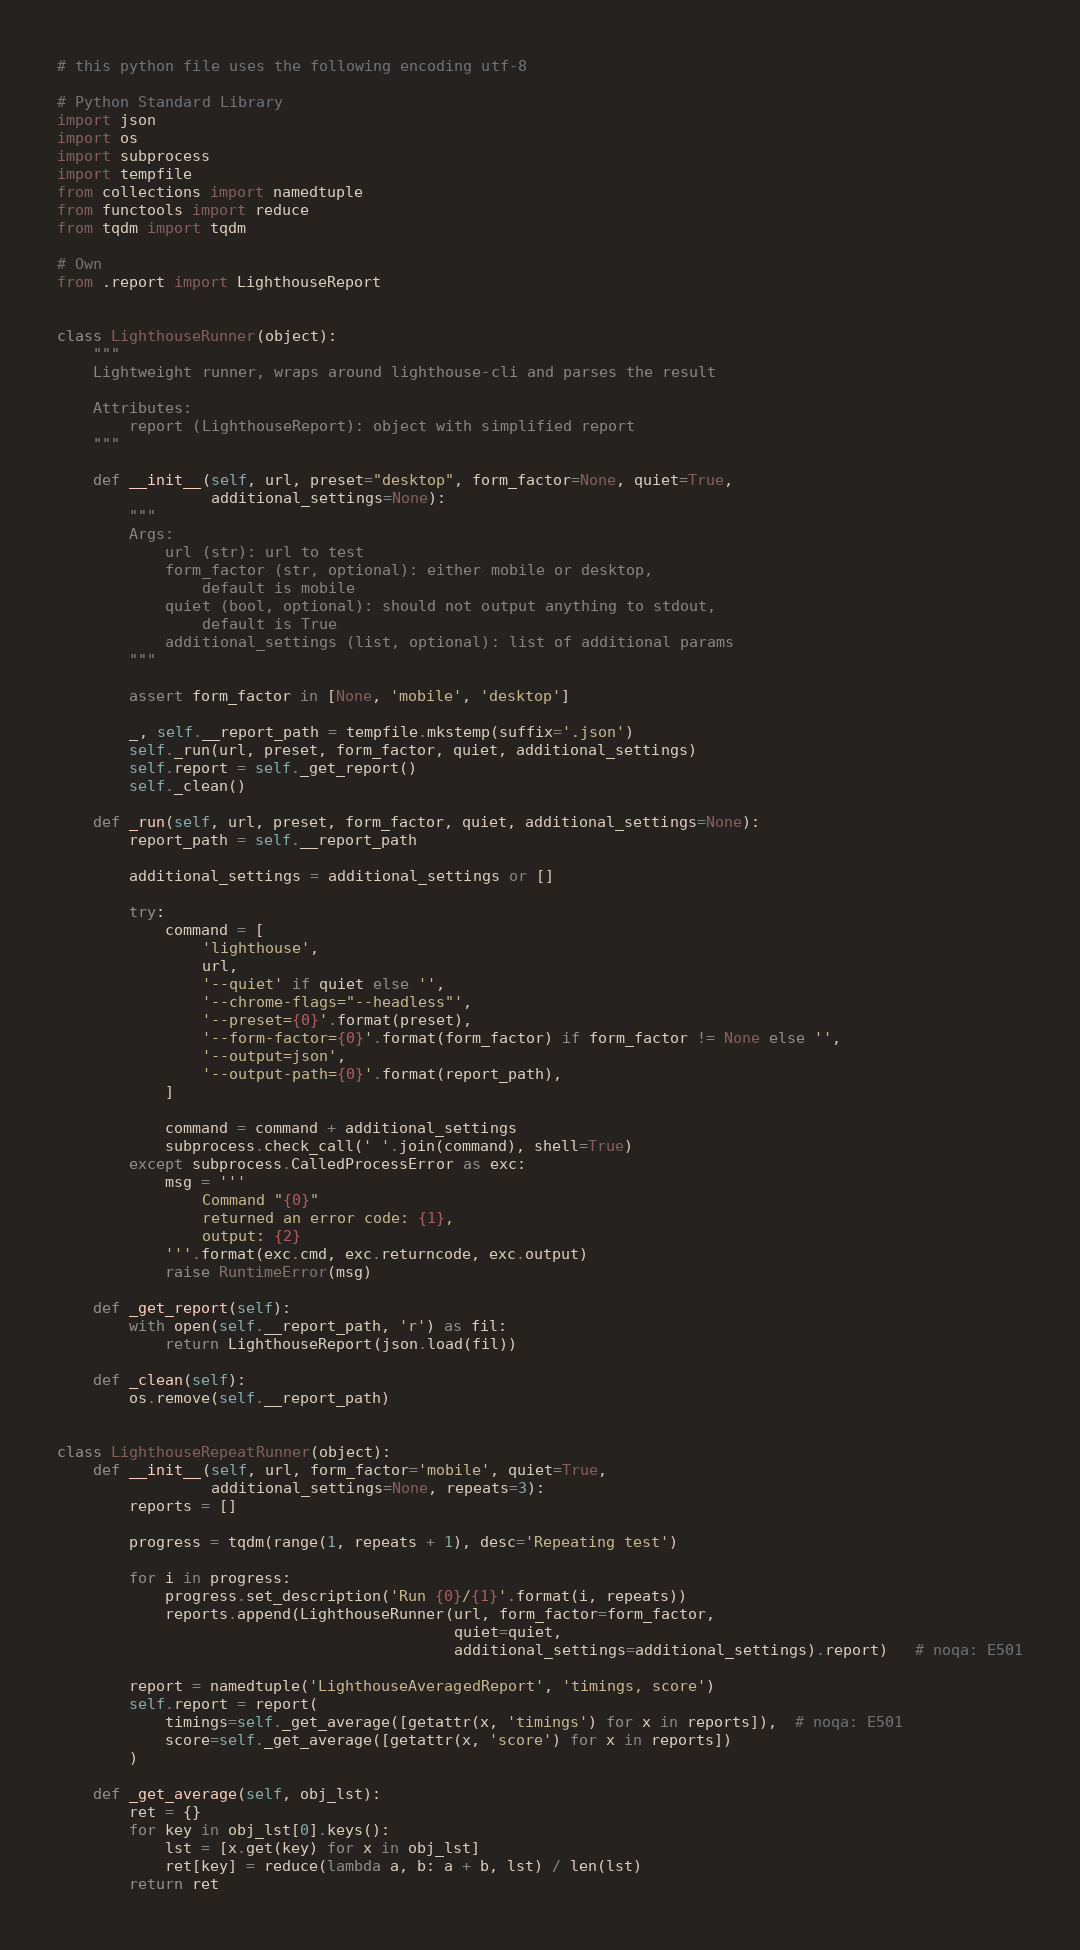<code> <loc_0><loc_0><loc_500><loc_500><_Python_># this python file uses the following encoding utf-8

# Python Standard Library
import json
import os
import subprocess
import tempfile
from collections import namedtuple
from functools import reduce
from tqdm import tqdm

# Own
from .report import LighthouseReport


class LighthouseRunner(object):
    """
    Lightweight runner, wraps around lighthouse-cli and parses the result

    Attributes:
        report (LighthouseReport): object with simplified report
    """

    def __init__(self, url, preset="desktop", form_factor=None, quiet=True,
                 additional_settings=None):
        """
        Args:
            url (str): url to test
            form_factor (str, optional): either mobile or desktop,
                default is mobile
            quiet (bool, optional): should not output anything to stdout,
                default is True
            additional_settings (list, optional): list of additional params
        """

        assert form_factor in [None, 'mobile', 'desktop']

        _, self.__report_path = tempfile.mkstemp(suffix='.json')
        self._run(url, preset, form_factor, quiet, additional_settings)
        self.report = self._get_report()
        self._clean()

    def _run(self, url, preset, form_factor, quiet, additional_settings=None):
        report_path = self.__report_path

        additional_settings = additional_settings or []

        try:
            command = [
                'lighthouse',
                url,
                '--quiet' if quiet else '',
                '--chrome-flags="--headless"',
                '--preset={0}'.format(preset),
                '--form-factor={0}'.format(form_factor) if form_factor != None else '',
                '--output=json',
                '--output-path={0}'.format(report_path),
            ]

            command = command + additional_settings
            subprocess.check_call(' '.join(command), shell=True)
        except subprocess.CalledProcessError as exc:
            msg = '''
                Command "{0}"
                returned an error code: {1},
                output: {2}
            '''.format(exc.cmd, exc.returncode, exc.output)
            raise RuntimeError(msg)

    def _get_report(self):
        with open(self.__report_path, 'r') as fil:
            return LighthouseReport(json.load(fil))

    def _clean(self):
        os.remove(self.__report_path)


class LighthouseRepeatRunner(object):
    def __init__(self, url, form_factor='mobile', quiet=True,
                 additional_settings=None, repeats=3):
        reports = []

        progress = tqdm(range(1, repeats + 1), desc='Repeating test')

        for i in progress:
            progress.set_description('Run {0}/{1}'.format(i, repeats))
            reports.append(LighthouseRunner(url, form_factor=form_factor,
                                            quiet=quiet,
                                            additional_settings=additional_settings).report)   # noqa: E501

        report = namedtuple('LighthouseAveragedReport', 'timings, score')
        self.report = report(
            timings=self._get_average([getattr(x, 'timings') for x in reports]),  # noqa: E501
            score=self._get_average([getattr(x, 'score') for x in reports])
        )

    def _get_average(self, obj_lst):
        ret = {}
        for key in obj_lst[0].keys():
            lst = [x.get(key) for x in obj_lst]
            ret[key] = reduce(lambda a, b: a + b, lst) / len(lst)
        return ret
</code> 